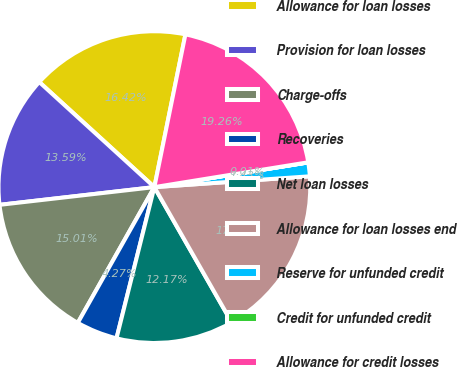Convert chart to OTSL. <chart><loc_0><loc_0><loc_500><loc_500><pie_chart><fcel>Allowance for loan losses<fcel>Provision for loan losses<fcel>Charge-offs<fcel>Recoveries<fcel>Net loan losses<fcel>Allowance for loan losses end<fcel>Reserve for unfunded credit<fcel>Credit for unfunded credit<fcel>Allowance for credit losses<nl><fcel>16.42%<fcel>13.59%<fcel>15.01%<fcel>4.27%<fcel>12.17%<fcel>17.84%<fcel>1.43%<fcel>0.01%<fcel>19.26%<nl></chart> 